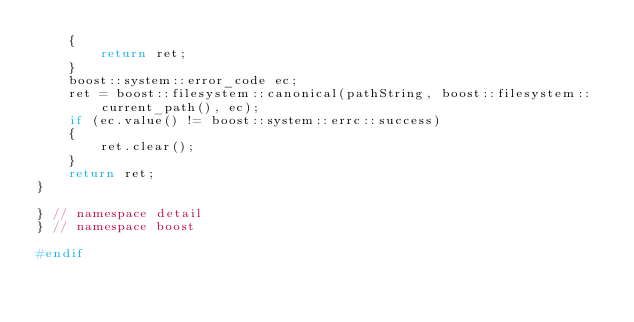<code> <loc_0><loc_0><loc_500><loc_500><_C++_>    {
        return ret;
    }
    boost::system::error_code ec;
    ret = boost::filesystem::canonical(pathString, boost::filesystem::current_path(), ec);
    if (ec.value() != boost::system::errc::success)
    {
        ret.clear();
    }
    return ret;
}

} // namespace detail
} // namespace boost

#endif
</code> 